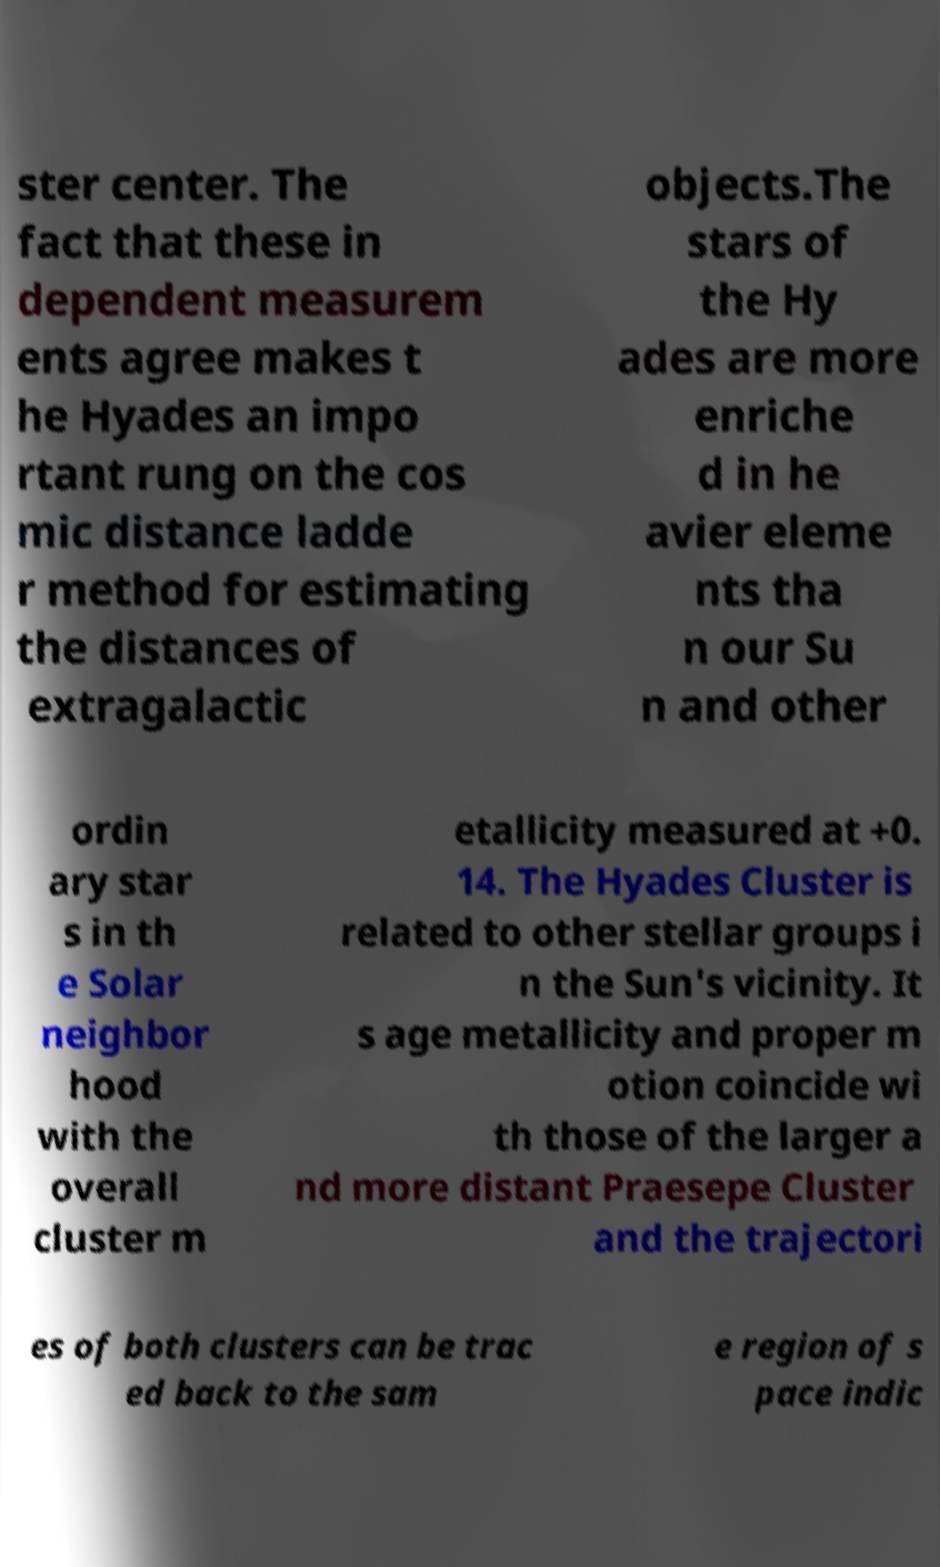Please read and relay the text visible in this image. What does it say? ster center. The fact that these in dependent measurem ents agree makes t he Hyades an impo rtant rung on the cos mic distance ladde r method for estimating the distances of extragalactic objects.The stars of the Hy ades are more enriche d in he avier eleme nts tha n our Su n and other ordin ary star s in th e Solar neighbor hood with the overall cluster m etallicity measured at +0. 14. The Hyades Cluster is related to other stellar groups i n the Sun's vicinity. It s age metallicity and proper m otion coincide wi th those of the larger a nd more distant Praesepe Cluster and the trajectori es of both clusters can be trac ed back to the sam e region of s pace indic 